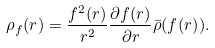Convert formula to latex. <formula><loc_0><loc_0><loc_500><loc_500>\rho _ { f } ( { r } ) = \frac { f ^ { 2 } ( { r } ) } { r ^ { 2 } } \frac { \partial f ( { r } ) } { \partial r } \bar { \rho } ( f ( { r ) } ) .</formula> 